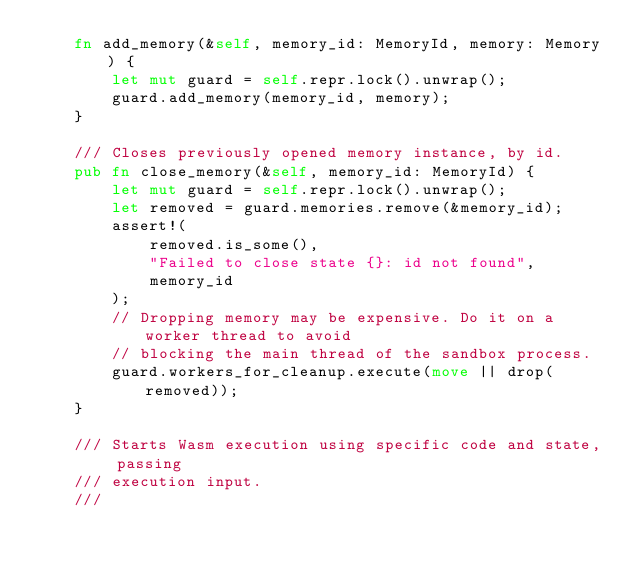<code> <loc_0><loc_0><loc_500><loc_500><_Rust_>    fn add_memory(&self, memory_id: MemoryId, memory: Memory) {
        let mut guard = self.repr.lock().unwrap();
        guard.add_memory(memory_id, memory);
    }

    /// Closes previously opened memory instance, by id.
    pub fn close_memory(&self, memory_id: MemoryId) {
        let mut guard = self.repr.lock().unwrap();
        let removed = guard.memories.remove(&memory_id);
        assert!(
            removed.is_some(),
            "Failed to close state {}: id not found",
            memory_id
        );
        // Dropping memory may be expensive. Do it on a worker thread to avoid
        // blocking the main thread of the sandbox process.
        guard.workers_for_cleanup.execute(move || drop(removed));
    }

    /// Starts Wasm execution using specific code and state, passing
    /// execution input.
    ///</code> 